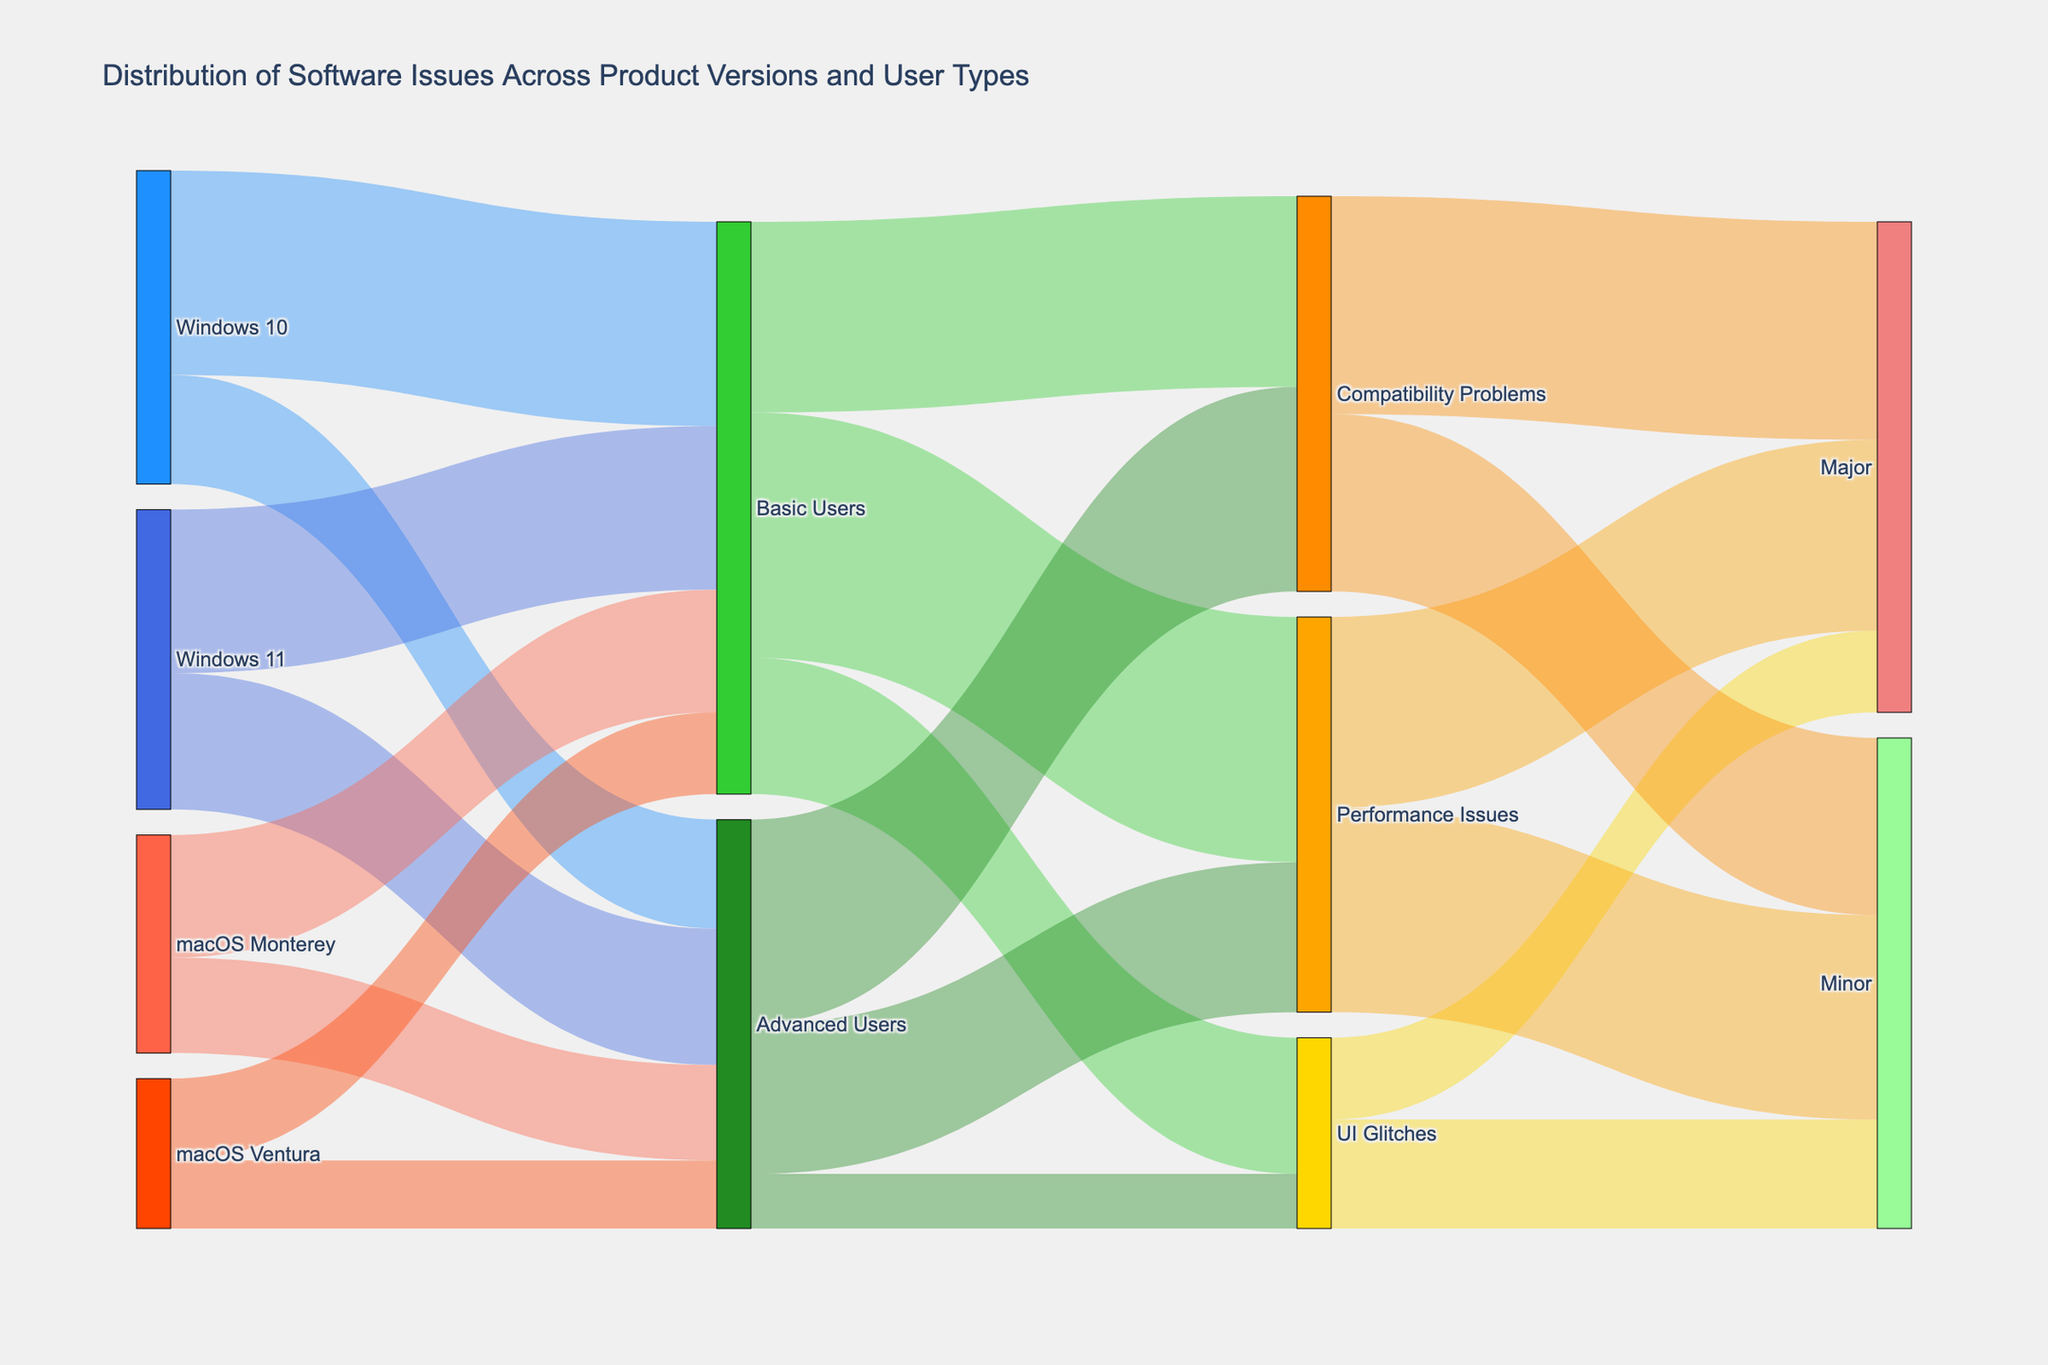What is the title of the figure? The title of the figure is typically found at the top and summarizes the content of the chart. In this case, it indicates the general subject of the data visualized in the Sankey diagram.
Answer: Distribution of Software Issues Across Product Versions and User Types What product version has the highest number of Basic Users? Look at the links originating from each product version to Basic Users. Identify which product version has the largest flow in terms of 'value'.
Answer: Windows 10 What is the total number of issues reported by Basic Users across all product versions? To find the total number of issues reported by Basic Users, sum the values from the links originating from 'Basic Users' to the specific issue types (UI Glitches, Performance Issues, Compatibility Problems). 150 (Windows 10) + 120 (Windows 11) + 90 (macOS Monterey) + 60 (macOS Ventura) = 420
Answer: 420 What type of issue is reported most frequently by Advanced Users? Look at the links originating from 'Advanced Users' to specific issue types and compare the values. Identify which issue type has the largest flow.
Answer: Compatibility Problems Which group reports more Performance Issues, Basic Users or Advanced Users? Identify the flows from both 'Basic Users' and 'Advanced Users' to 'Performance Issues'. Compare the summation of 'value' in each link. Basic Users to Performance Issues = 180, Advanced Users to Performance Issues = 110.
Answer: Basic Users How many major issues are reported in total? Sum up the values of the links ending at 'Major' for different issue types (UI Glitches, Performance Issues, Compatibility Problems). 60 (UI Glitches) + 140 (Performance Issues) + 160 (Compatibility Problems) = 360
Answer: 360 From which product version do we see the least number of Advanced Users? Compare the links originating from product versions to 'Advanced Users'. The value with the smallest number will indicate the product version with the least number of Advanced Users.
Answer: macOS Ventura What is the total number of minor issues reported for Compatibility Problems? Sum up the values of the links ending at 'Minor' from 'Compatibility Problems'.
Answer: 130 